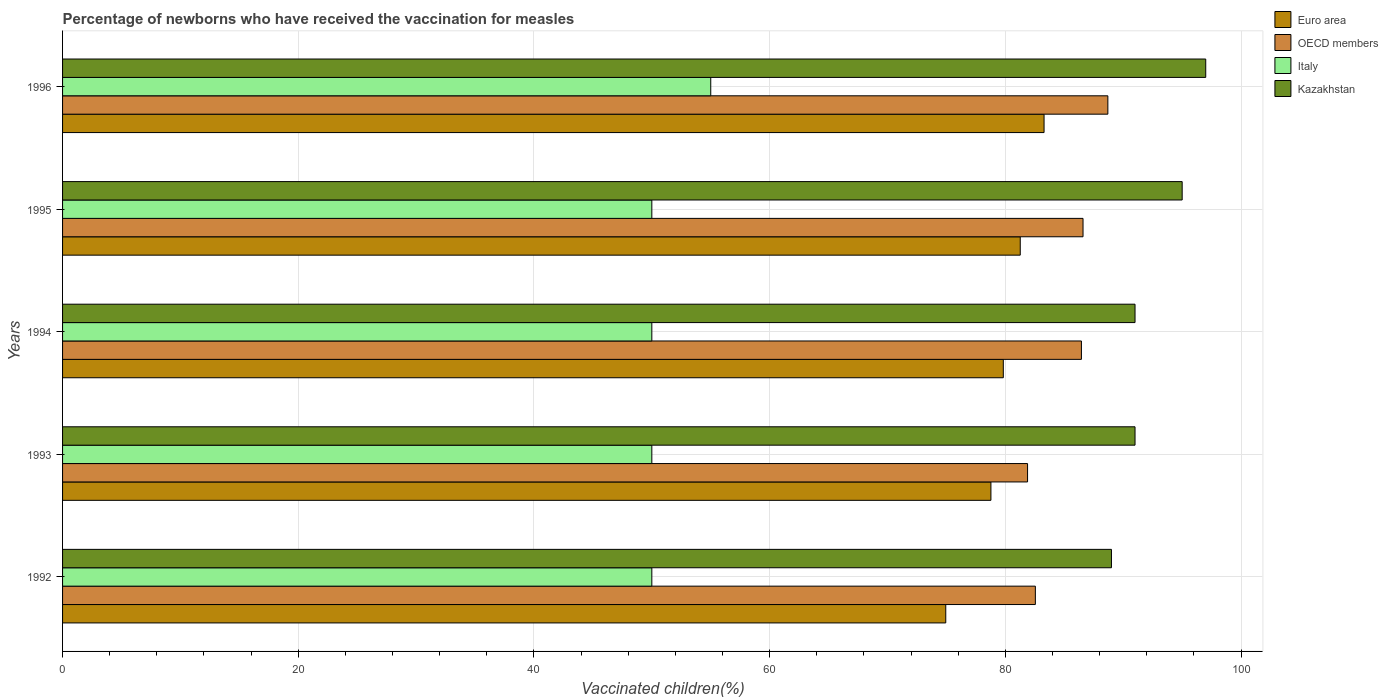How many different coloured bars are there?
Offer a very short reply. 4. Are the number of bars on each tick of the Y-axis equal?
Offer a very short reply. Yes. What is the label of the 2nd group of bars from the top?
Offer a very short reply. 1995. In how many cases, is the number of bars for a given year not equal to the number of legend labels?
Your answer should be very brief. 0. What is the percentage of vaccinated children in Kazakhstan in 1994?
Offer a very short reply. 91. Across all years, what is the maximum percentage of vaccinated children in Italy?
Offer a very short reply. 55. Across all years, what is the minimum percentage of vaccinated children in OECD members?
Your answer should be compact. 81.88. What is the total percentage of vaccinated children in OECD members in the graph?
Your answer should be very brief. 426.16. What is the difference between the percentage of vaccinated children in OECD members in 1994 and the percentage of vaccinated children in Italy in 1993?
Your answer should be very brief. 36.45. What is the average percentage of vaccinated children in Italy per year?
Make the answer very short. 51. In the year 1995, what is the difference between the percentage of vaccinated children in OECD members and percentage of vaccinated children in Italy?
Your answer should be compact. 36.59. What is the ratio of the percentage of vaccinated children in Euro area in 1992 to that in 1993?
Your answer should be very brief. 0.95. Is the percentage of vaccinated children in Italy in 1993 less than that in 1995?
Your response must be concise. No. What is the difference between the highest and the second highest percentage of vaccinated children in Euro area?
Keep it short and to the point. 2.02. What is the difference between the highest and the lowest percentage of vaccinated children in Italy?
Make the answer very short. 5. Is the sum of the percentage of vaccinated children in Italy in 1993 and 1996 greater than the maximum percentage of vaccinated children in OECD members across all years?
Give a very brief answer. Yes. Is it the case that in every year, the sum of the percentage of vaccinated children in Kazakhstan and percentage of vaccinated children in Euro area is greater than the sum of percentage of vaccinated children in Italy and percentage of vaccinated children in OECD members?
Ensure brevity in your answer.  Yes. What does the 4th bar from the top in 1993 represents?
Keep it short and to the point. Euro area. What does the 3rd bar from the bottom in 1992 represents?
Keep it short and to the point. Italy. Are all the bars in the graph horizontal?
Offer a very short reply. Yes. Are the values on the major ticks of X-axis written in scientific E-notation?
Offer a very short reply. No. Does the graph contain any zero values?
Ensure brevity in your answer.  No. Does the graph contain grids?
Offer a very short reply. Yes. Where does the legend appear in the graph?
Your response must be concise. Top right. How many legend labels are there?
Your answer should be very brief. 4. What is the title of the graph?
Keep it short and to the point. Percentage of newborns who have received the vaccination for measles. What is the label or title of the X-axis?
Provide a succinct answer. Vaccinated children(%). What is the label or title of the Y-axis?
Offer a terse response. Years. What is the Vaccinated children(%) in Euro area in 1992?
Your answer should be compact. 74.94. What is the Vaccinated children(%) in OECD members in 1992?
Offer a terse response. 82.54. What is the Vaccinated children(%) of Italy in 1992?
Make the answer very short. 50. What is the Vaccinated children(%) of Kazakhstan in 1992?
Provide a succinct answer. 89. What is the Vaccinated children(%) in Euro area in 1993?
Ensure brevity in your answer.  78.77. What is the Vaccinated children(%) in OECD members in 1993?
Offer a terse response. 81.88. What is the Vaccinated children(%) of Kazakhstan in 1993?
Make the answer very short. 91. What is the Vaccinated children(%) of Euro area in 1994?
Give a very brief answer. 79.82. What is the Vaccinated children(%) of OECD members in 1994?
Your response must be concise. 86.45. What is the Vaccinated children(%) of Kazakhstan in 1994?
Make the answer very short. 91. What is the Vaccinated children(%) in Euro area in 1995?
Give a very brief answer. 81.26. What is the Vaccinated children(%) of OECD members in 1995?
Keep it short and to the point. 86.59. What is the Vaccinated children(%) of Kazakhstan in 1995?
Your answer should be very brief. 95. What is the Vaccinated children(%) in Euro area in 1996?
Make the answer very short. 83.28. What is the Vaccinated children(%) in OECD members in 1996?
Ensure brevity in your answer.  88.69. What is the Vaccinated children(%) of Italy in 1996?
Ensure brevity in your answer.  55. What is the Vaccinated children(%) of Kazakhstan in 1996?
Your answer should be compact. 97. Across all years, what is the maximum Vaccinated children(%) of Euro area?
Your response must be concise. 83.28. Across all years, what is the maximum Vaccinated children(%) in OECD members?
Give a very brief answer. 88.69. Across all years, what is the maximum Vaccinated children(%) in Italy?
Your answer should be compact. 55. Across all years, what is the maximum Vaccinated children(%) of Kazakhstan?
Your answer should be compact. 97. Across all years, what is the minimum Vaccinated children(%) of Euro area?
Provide a succinct answer. 74.94. Across all years, what is the minimum Vaccinated children(%) in OECD members?
Ensure brevity in your answer.  81.88. Across all years, what is the minimum Vaccinated children(%) of Italy?
Provide a succinct answer. 50. Across all years, what is the minimum Vaccinated children(%) in Kazakhstan?
Offer a terse response. 89. What is the total Vaccinated children(%) in Euro area in the graph?
Provide a short and direct response. 398.08. What is the total Vaccinated children(%) of OECD members in the graph?
Give a very brief answer. 426.16. What is the total Vaccinated children(%) of Italy in the graph?
Provide a short and direct response. 255. What is the total Vaccinated children(%) of Kazakhstan in the graph?
Make the answer very short. 463. What is the difference between the Vaccinated children(%) in Euro area in 1992 and that in 1993?
Provide a short and direct response. -3.83. What is the difference between the Vaccinated children(%) in OECD members in 1992 and that in 1993?
Provide a short and direct response. 0.66. What is the difference between the Vaccinated children(%) in Italy in 1992 and that in 1993?
Make the answer very short. 0. What is the difference between the Vaccinated children(%) of Euro area in 1992 and that in 1994?
Your response must be concise. -4.88. What is the difference between the Vaccinated children(%) of OECD members in 1992 and that in 1994?
Ensure brevity in your answer.  -3.91. What is the difference between the Vaccinated children(%) in Italy in 1992 and that in 1994?
Offer a very short reply. 0. What is the difference between the Vaccinated children(%) of Kazakhstan in 1992 and that in 1994?
Provide a succinct answer. -2. What is the difference between the Vaccinated children(%) in Euro area in 1992 and that in 1995?
Your answer should be very brief. -6.32. What is the difference between the Vaccinated children(%) of OECD members in 1992 and that in 1995?
Make the answer very short. -4.04. What is the difference between the Vaccinated children(%) of Italy in 1992 and that in 1995?
Make the answer very short. 0. What is the difference between the Vaccinated children(%) of Kazakhstan in 1992 and that in 1995?
Ensure brevity in your answer.  -6. What is the difference between the Vaccinated children(%) of Euro area in 1992 and that in 1996?
Make the answer very short. -8.34. What is the difference between the Vaccinated children(%) of OECD members in 1992 and that in 1996?
Provide a short and direct response. -6.15. What is the difference between the Vaccinated children(%) in Euro area in 1993 and that in 1994?
Keep it short and to the point. -1.05. What is the difference between the Vaccinated children(%) in OECD members in 1993 and that in 1994?
Provide a short and direct response. -4.57. What is the difference between the Vaccinated children(%) of Kazakhstan in 1993 and that in 1994?
Keep it short and to the point. 0. What is the difference between the Vaccinated children(%) in Euro area in 1993 and that in 1995?
Ensure brevity in your answer.  -2.49. What is the difference between the Vaccinated children(%) in OECD members in 1993 and that in 1995?
Provide a short and direct response. -4.71. What is the difference between the Vaccinated children(%) of Italy in 1993 and that in 1995?
Your answer should be very brief. 0. What is the difference between the Vaccinated children(%) in Euro area in 1993 and that in 1996?
Your response must be concise. -4.51. What is the difference between the Vaccinated children(%) in OECD members in 1993 and that in 1996?
Ensure brevity in your answer.  -6.81. What is the difference between the Vaccinated children(%) in Italy in 1993 and that in 1996?
Give a very brief answer. -5. What is the difference between the Vaccinated children(%) of Euro area in 1994 and that in 1995?
Give a very brief answer. -1.44. What is the difference between the Vaccinated children(%) of OECD members in 1994 and that in 1995?
Make the answer very short. -0.14. What is the difference between the Vaccinated children(%) in Italy in 1994 and that in 1995?
Give a very brief answer. 0. What is the difference between the Vaccinated children(%) of Euro area in 1994 and that in 1996?
Your answer should be compact. -3.46. What is the difference between the Vaccinated children(%) in OECD members in 1994 and that in 1996?
Your response must be concise. -2.24. What is the difference between the Vaccinated children(%) of Italy in 1994 and that in 1996?
Offer a very short reply. -5. What is the difference between the Vaccinated children(%) of Kazakhstan in 1994 and that in 1996?
Ensure brevity in your answer.  -6. What is the difference between the Vaccinated children(%) of Euro area in 1995 and that in 1996?
Give a very brief answer. -2.02. What is the difference between the Vaccinated children(%) in OECD members in 1995 and that in 1996?
Your answer should be compact. -2.11. What is the difference between the Vaccinated children(%) of Italy in 1995 and that in 1996?
Provide a succinct answer. -5. What is the difference between the Vaccinated children(%) of Euro area in 1992 and the Vaccinated children(%) of OECD members in 1993?
Keep it short and to the point. -6.94. What is the difference between the Vaccinated children(%) of Euro area in 1992 and the Vaccinated children(%) of Italy in 1993?
Provide a succinct answer. 24.94. What is the difference between the Vaccinated children(%) of Euro area in 1992 and the Vaccinated children(%) of Kazakhstan in 1993?
Your answer should be compact. -16.06. What is the difference between the Vaccinated children(%) in OECD members in 1992 and the Vaccinated children(%) in Italy in 1993?
Give a very brief answer. 32.54. What is the difference between the Vaccinated children(%) in OECD members in 1992 and the Vaccinated children(%) in Kazakhstan in 1993?
Give a very brief answer. -8.46. What is the difference between the Vaccinated children(%) in Italy in 1992 and the Vaccinated children(%) in Kazakhstan in 1993?
Keep it short and to the point. -41. What is the difference between the Vaccinated children(%) of Euro area in 1992 and the Vaccinated children(%) of OECD members in 1994?
Make the answer very short. -11.51. What is the difference between the Vaccinated children(%) in Euro area in 1992 and the Vaccinated children(%) in Italy in 1994?
Provide a short and direct response. 24.94. What is the difference between the Vaccinated children(%) of Euro area in 1992 and the Vaccinated children(%) of Kazakhstan in 1994?
Offer a very short reply. -16.06. What is the difference between the Vaccinated children(%) in OECD members in 1992 and the Vaccinated children(%) in Italy in 1994?
Your answer should be very brief. 32.54. What is the difference between the Vaccinated children(%) of OECD members in 1992 and the Vaccinated children(%) of Kazakhstan in 1994?
Provide a succinct answer. -8.46. What is the difference between the Vaccinated children(%) in Italy in 1992 and the Vaccinated children(%) in Kazakhstan in 1994?
Ensure brevity in your answer.  -41. What is the difference between the Vaccinated children(%) in Euro area in 1992 and the Vaccinated children(%) in OECD members in 1995?
Make the answer very short. -11.65. What is the difference between the Vaccinated children(%) of Euro area in 1992 and the Vaccinated children(%) of Italy in 1995?
Offer a terse response. 24.94. What is the difference between the Vaccinated children(%) in Euro area in 1992 and the Vaccinated children(%) in Kazakhstan in 1995?
Your answer should be compact. -20.06. What is the difference between the Vaccinated children(%) in OECD members in 1992 and the Vaccinated children(%) in Italy in 1995?
Give a very brief answer. 32.54. What is the difference between the Vaccinated children(%) of OECD members in 1992 and the Vaccinated children(%) of Kazakhstan in 1995?
Your response must be concise. -12.46. What is the difference between the Vaccinated children(%) in Italy in 1992 and the Vaccinated children(%) in Kazakhstan in 1995?
Your answer should be very brief. -45. What is the difference between the Vaccinated children(%) of Euro area in 1992 and the Vaccinated children(%) of OECD members in 1996?
Your response must be concise. -13.75. What is the difference between the Vaccinated children(%) in Euro area in 1992 and the Vaccinated children(%) in Italy in 1996?
Your answer should be compact. 19.94. What is the difference between the Vaccinated children(%) of Euro area in 1992 and the Vaccinated children(%) of Kazakhstan in 1996?
Offer a very short reply. -22.06. What is the difference between the Vaccinated children(%) of OECD members in 1992 and the Vaccinated children(%) of Italy in 1996?
Your response must be concise. 27.54. What is the difference between the Vaccinated children(%) in OECD members in 1992 and the Vaccinated children(%) in Kazakhstan in 1996?
Give a very brief answer. -14.46. What is the difference between the Vaccinated children(%) of Italy in 1992 and the Vaccinated children(%) of Kazakhstan in 1996?
Make the answer very short. -47. What is the difference between the Vaccinated children(%) in Euro area in 1993 and the Vaccinated children(%) in OECD members in 1994?
Your response must be concise. -7.68. What is the difference between the Vaccinated children(%) of Euro area in 1993 and the Vaccinated children(%) of Italy in 1994?
Your answer should be very brief. 28.77. What is the difference between the Vaccinated children(%) in Euro area in 1993 and the Vaccinated children(%) in Kazakhstan in 1994?
Ensure brevity in your answer.  -12.23. What is the difference between the Vaccinated children(%) in OECD members in 1993 and the Vaccinated children(%) in Italy in 1994?
Offer a very short reply. 31.88. What is the difference between the Vaccinated children(%) of OECD members in 1993 and the Vaccinated children(%) of Kazakhstan in 1994?
Your answer should be very brief. -9.12. What is the difference between the Vaccinated children(%) of Italy in 1993 and the Vaccinated children(%) of Kazakhstan in 1994?
Offer a very short reply. -41. What is the difference between the Vaccinated children(%) in Euro area in 1993 and the Vaccinated children(%) in OECD members in 1995?
Give a very brief answer. -7.82. What is the difference between the Vaccinated children(%) of Euro area in 1993 and the Vaccinated children(%) of Italy in 1995?
Your response must be concise. 28.77. What is the difference between the Vaccinated children(%) of Euro area in 1993 and the Vaccinated children(%) of Kazakhstan in 1995?
Your response must be concise. -16.23. What is the difference between the Vaccinated children(%) of OECD members in 1993 and the Vaccinated children(%) of Italy in 1995?
Make the answer very short. 31.88. What is the difference between the Vaccinated children(%) of OECD members in 1993 and the Vaccinated children(%) of Kazakhstan in 1995?
Your answer should be compact. -13.12. What is the difference between the Vaccinated children(%) of Italy in 1993 and the Vaccinated children(%) of Kazakhstan in 1995?
Make the answer very short. -45. What is the difference between the Vaccinated children(%) of Euro area in 1993 and the Vaccinated children(%) of OECD members in 1996?
Provide a succinct answer. -9.92. What is the difference between the Vaccinated children(%) of Euro area in 1993 and the Vaccinated children(%) of Italy in 1996?
Make the answer very short. 23.77. What is the difference between the Vaccinated children(%) in Euro area in 1993 and the Vaccinated children(%) in Kazakhstan in 1996?
Provide a succinct answer. -18.23. What is the difference between the Vaccinated children(%) in OECD members in 1993 and the Vaccinated children(%) in Italy in 1996?
Provide a short and direct response. 26.88. What is the difference between the Vaccinated children(%) in OECD members in 1993 and the Vaccinated children(%) in Kazakhstan in 1996?
Keep it short and to the point. -15.12. What is the difference between the Vaccinated children(%) of Italy in 1993 and the Vaccinated children(%) of Kazakhstan in 1996?
Your response must be concise. -47. What is the difference between the Vaccinated children(%) in Euro area in 1994 and the Vaccinated children(%) in OECD members in 1995?
Give a very brief answer. -6.76. What is the difference between the Vaccinated children(%) of Euro area in 1994 and the Vaccinated children(%) of Italy in 1995?
Provide a succinct answer. 29.82. What is the difference between the Vaccinated children(%) in Euro area in 1994 and the Vaccinated children(%) in Kazakhstan in 1995?
Offer a terse response. -15.18. What is the difference between the Vaccinated children(%) in OECD members in 1994 and the Vaccinated children(%) in Italy in 1995?
Your answer should be very brief. 36.45. What is the difference between the Vaccinated children(%) of OECD members in 1994 and the Vaccinated children(%) of Kazakhstan in 1995?
Your response must be concise. -8.55. What is the difference between the Vaccinated children(%) of Italy in 1994 and the Vaccinated children(%) of Kazakhstan in 1995?
Keep it short and to the point. -45. What is the difference between the Vaccinated children(%) of Euro area in 1994 and the Vaccinated children(%) of OECD members in 1996?
Provide a succinct answer. -8.87. What is the difference between the Vaccinated children(%) in Euro area in 1994 and the Vaccinated children(%) in Italy in 1996?
Provide a short and direct response. 24.82. What is the difference between the Vaccinated children(%) in Euro area in 1994 and the Vaccinated children(%) in Kazakhstan in 1996?
Your answer should be very brief. -17.18. What is the difference between the Vaccinated children(%) of OECD members in 1994 and the Vaccinated children(%) of Italy in 1996?
Ensure brevity in your answer.  31.45. What is the difference between the Vaccinated children(%) in OECD members in 1994 and the Vaccinated children(%) in Kazakhstan in 1996?
Your response must be concise. -10.55. What is the difference between the Vaccinated children(%) in Italy in 1994 and the Vaccinated children(%) in Kazakhstan in 1996?
Keep it short and to the point. -47. What is the difference between the Vaccinated children(%) of Euro area in 1995 and the Vaccinated children(%) of OECD members in 1996?
Provide a succinct answer. -7.43. What is the difference between the Vaccinated children(%) in Euro area in 1995 and the Vaccinated children(%) in Italy in 1996?
Ensure brevity in your answer.  26.26. What is the difference between the Vaccinated children(%) of Euro area in 1995 and the Vaccinated children(%) of Kazakhstan in 1996?
Your answer should be compact. -15.74. What is the difference between the Vaccinated children(%) in OECD members in 1995 and the Vaccinated children(%) in Italy in 1996?
Make the answer very short. 31.59. What is the difference between the Vaccinated children(%) in OECD members in 1995 and the Vaccinated children(%) in Kazakhstan in 1996?
Provide a short and direct response. -10.41. What is the difference between the Vaccinated children(%) in Italy in 1995 and the Vaccinated children(%) in Kazakhstan in 1996?
Ensure brevity in your answer.  -47. What is the average Vaccinated children(%) in Euro area per year?
Ensure brevity in your answer.  79.62. What is the average Vaccinated children(%) of OECD members per year?
Provide a short and direct response. 85.23. What is the average Vaccinated children(%) in Kazakhstan per year?
Provide a succinct answer. 92.6. In the year 1992, what is the difference between the Vaccinated children(%) of Euro area and Vaccinated children(%) of OECD members?
Provide a succinct answer. -7.6. In the year 1992, what is the difference between the Vaccinated children(%) of Euro area and Vaccinated children(%) of Italy?
Offer a very short reply. 24.94. In the year 1992, what is the difference between the Vaccinated children(%) in Euro area and Vaccinated children(%) in Kazakhstan?
Keep it short and to the point. -14.06. In the year 1992, what is the difference between the Vaccinated children(%) in OECD members and Vaccinated children(%) in Italy?
Offer a terse response. 32.54. In the year 1992, what is the difference between the Vaccinated children(%) in OECD members and Vaccinated children(%) in Kazakhstan?
Provide a short and direct response. -6.46. In the year 1992, what is the difference between the Vaccinated children(%) of Italy and Vaccinated children(%) of Kazakhstan?
Keep it short and to the point. -39. In the year 1993, what is the difference between the Vaccinated children(%) in Euro area and Vaccinated children(%) in OECD members?
Ensure brevity in your answer.  -3.11. In the year 1993, what is the difference between the Vaccinated children(%) of Euro area and Vaccinated children(%) of Italy?
Offer a very short reply. 28.77. In the year 1993, what is the difference between the Vaccinated children(%) of Euro area and Vaccinated children(%) of Kazakhstan?
Give a very brief answer. -12.23. In the year 1993, what is the difference between the Vaccinated children(%) in OECD members and Vaccinated children(%) in Italy?
Make the answer very short. 31.88. In the year 1993, what is the difference between the Vaccinated children(%) of OECD members and Vaccinated children(%) of Kazakhstan?
Offer a terse response. -9.12. In the year 1993, what is the difference between the Vaccinated children(%) of Italy and Vaccinated children(%) of Kazakhstan?
Provide a short and direct response. -41. In the year 1994, what is the difference between the Vaccinated children(%) of Euro area and Vaccinated children(%) of OECD members?
Your answer should be very brief. -6.63. In the year 1994, what is the difference between the Vaccinated children(%) in Euro area and Vaccinated children(%) in Italy?
Give a very brief answer. 29.82. In the year 1994, what is the difference between the Vaccinated children(%) in Euro area and Vaccinated children(%) in Kazakhstan?
Ensure brevity in your answer.  -11.18. In the year 1994, what is the difference between the Vaccinated children(%) of OECD members and Vaccinated children(%) of Italy?
Your answer should be compact. 36.45. In the year 1994, what is the difference between the Vaccinated children(%) in OECD members and Vaccinated children(%) in Kazakhstan?
Provide a succinct answer. -4.55. In the year 1994, what is the difference between the Vaccinated children(%) of Italy and Vaccinated children(%) of Kazakhstan?
Ensure brevity in your answer.  -41. In the year 1995, what is the difference between the Vaccinated children(%) in Euro area and Vaccinated children(%) in OECD members?
Ensure brevity in your answer.  -5.33. In the year 1995, what is the difference between the Vaccinated children(%) of Euro area and Vaccinated children(%) of Italy?
Your answer should be very brief. 31.26. In the year 1995, what is the difference between the Vaccinated children(%) in Euro area and Vaccinated children(%) in Kazakhstan?
Give a very brief answer. -13.74. In the year 1995, what is the difference between the Vaccinated children(%) of OECD members and Vaccinated children(%) of Italy?
Offer a terse response. 36.59. In the year 1995, what is the difference between the Vaccinated children(%) in OECD members and Vaccinated children(%) in Kazakhstan?
Your response must be concise. -8.41. In the year 1995, what is the difference between the Vaccinated children(%) in Italy and Vaccinated children(%) in Kazakhstan?
Ensure brevity in your answer.  -45. In the year 1996, what is the difference between the Vaccinated children(%) of Euro area and Vaccinated children(%) of OECD members?
Ensure brevity in your answer.  -5.41. In the year 1996, what is the difference between the Vaccinated children(%) of Euro area and Vaccinated children(%) of Italy?
Ensure brevity in your answer.  28.28. In the year 1996, what is the difference between the Vaccinated children(%) in Euro area and Vaccinated children(%) in Kazakhstan?
Ensure brevity in your answer.  -13.72. In the year 1996, what is the difference between the Vaccinated children(%) of OECD members and Vaccinated children(%) of Italy?
Make the answer very short. 33.69. In the year 1996, what is the difference between the Vaccinated children(%) in OECD members and Vaccinated children(%) in Kazakhstan?
Your response must be concise. -8.31. In the year 1996, what is the difference between the Vaccinated children(%) of Italy and Vaccinated children(%) of Kazakhstan?
Provide a succinct answer. -42. What is the ratio of the Vaccinated children(%) in Euro area in 1992 to that in 1993?
Your answer should be very brief. 0.95. What is the ratio of the Vaccinated children(%) in Italy in 1992 to that in 1993?
Your response must be concise. 1. What is the ratio of the Vaccinated children(%) of Kazakhstan in 1992 to that in 1993?
Keep it short and to the point. 0.98. What is the ratio of the Vaccinated children(%) of Euro area in 1992 to that in 1994?
Provide a succinct answer. 0.94. What is the ratio of the Vaccinated children(%) of OECD members in 1992 to that in 1994?
Your answer should be very brief. 0.95. What is the ratio of the Vaccinated children(%) of Euro area in 1992 to that in 1995?
Your answer should be very brief. 0.92. What is the ratio of the Vaccinated children(%) in OECD members in 1992 to that in 1995?
Your answer should be very brief. 0.95. What is the ratio of the Vaccinated children(%) of Kazakhstan in 1992 to that in 1995?
Your answer should be very brief. 0.94. What is the ratio of the Vaccinated children(%) of Euro area in 1992 to that in 1996?
Provide a succinct answer. 0.9. What is the ratio of the Vaccinated children(%) in OECD members in 1992 to that in 1996?
Keep it short and to the point. 0.93. What is the ratio of the Vaccinated children(%) of Kazakhstan in 1992 to that in 1996?
Provide a short and direct response. 0.92. What is the ratio of the Vaccinated children(%) of OECD members in 1993 to that in 1994?
Your answer should be very brief. 0.95. What is the ratio of the Vaccinated children(%) in Italy in 1993 to that in 1994?
Your answer should be compact. 1. What is the ratio of the Vaccinated children(%) in Kazakhstan in 1993 to that in 1994?
Make the answer very short. 1. What is the ratio of the Vaccinated children(%) of Euro area in 1993 to that in 1995?
Offer a terse response. 0.97. What is the ratio of the Vaccinated children(%) in OECD members in 1993 to that in 1995?
Ensure brevity in your answer.  0.95. What is the ratio of the Vaccinated children(%) in Italy in 1993 to that in 1995?
Your answer should be compact. 1. What is the ratio of the Vaccinated children(%) of Kazakhstan in 1993 to that in 1995?
Your answer should be very brief. 0.96. What is the ratio of the Vaccinated children(%) of Euro area in 1993 to that in 1996?
Ensure brevity in your answer.  0.95. What is the ratio of the Vaccinated children(%) of OECD members in 1993 to that in 1996?
Your answer should be compact. 0.92. What is the ratio of the Vaccinated children(%) of Kazakhstan in 1993 to that in 1996?
Provide a succinct answer. 0.94. What is the ratio of the Vaccinated children(%) of Euro area in 1994 to that in 1995?
Give a very brief answer. 0.98. What is the ratio of the Vaccinated children(%) of OECD members in 1994 to that in 1995?
Provide a succinct answer. 1. What is the ratio of the Vaccinated children(%) in Kazakhstan in 1994 to that in 1995?
Your answer should be compact. 0.96. What is the ratio of the Vaccinated children(%) in Euro area in 1994 to that in 1996?
Provide a succinct answer. 0.96. What is the ratio of the Vaccinated children(%) in OECD members in 1994 to that in 1996?
Make the answer very short. 0.97. What is the ratio of the Vaccinated children(%) in Kazakhstan in 1994 to that in 1996?
Your answer should be very brief. 0.94. What is the ratio of the Vaccinated children(%) in Euro area in 1995 to that in 1996?
Your answer should be very brief. 0.98. What is the ratio of the Vaccinated children(%) in OECD members in 1995 to that in 1996?
Give a very brief answer. 0.98. What is the ratio of the Vaccinated children(%) of Kazakhstan in 1995 to that in 1996?
Offer a terse response. 0.98. What is the difference between the highest and the second highest Vaccinated children(%) in Euro area?
Give a very brief answer. 2.02. What is the difference between the highest and the second highest Vaccinated children(%) of OECD members?
Give a very brief answer. 2.11. What is the difference between the highest and the second highest Vaccinated children(%) of Kazakhstan?
Your response must be concise. 2. What is the difference between the highest and the lowest Vaccinated children(%) of Euro area?
Offer a terse response. 8.34. What is the difference between the highest and the lowest Vaccinated children(%) in OECD members?
Give a very brief answer. 6.81. 